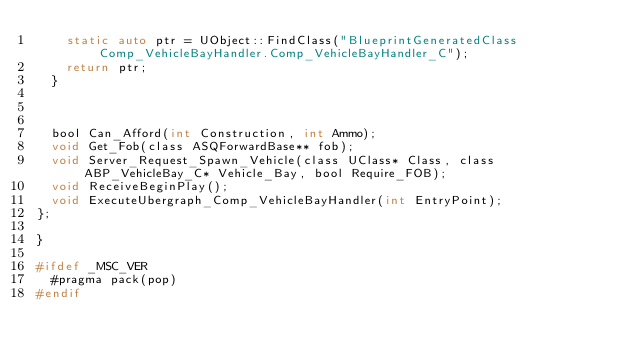<code> <loc_0><loc_0><loc_500><loc_500><_C_>		static auto ptr = UObject::FindClass("BlueprintGeneratedClass Comp_VehicleBayHandler.Comp_VehicleBayHandler_C");
		return ptr;
	}



	bool Can_Afford(int Construction, int Ammo);
	void Get_Fob(class ASQForwardBase** fob);
	void Server_Request_Spawn_Vehicle(class UClass* Class, class ABP_VehicleBay_C* Vehicle_Bay, bool Require_FOB);
	void ReceiveBeginPlay();
	void ExecuteUbergraph_Comp_VehicleBayHandler(int EntryPoint);
};

}

#ifdef _MSC_VER
	#pragma pack(pop)
#endif
</code> 